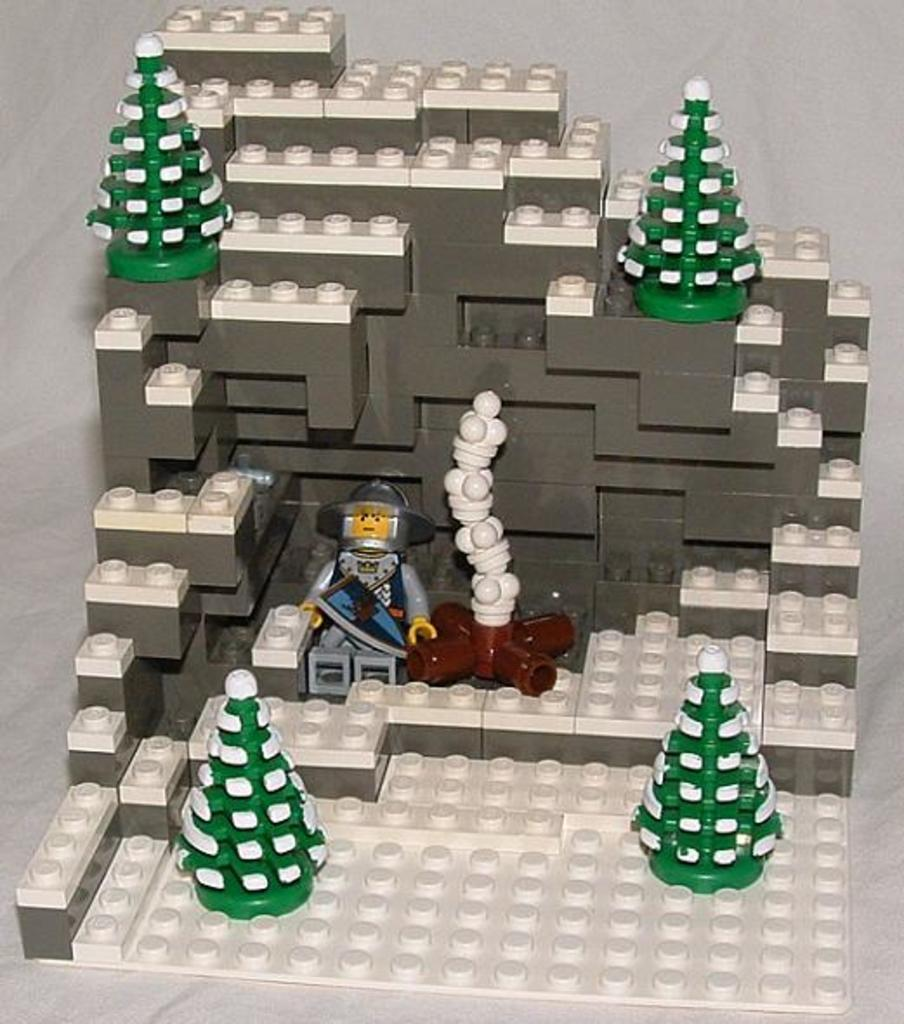What is the main structure visible in the image? There is a building in the image. What material is the building made of? The building is made with lego blocks. What type of leather is used to decorate the building in the image? There is no leather present in the image, as the building is made with lego blocks. 